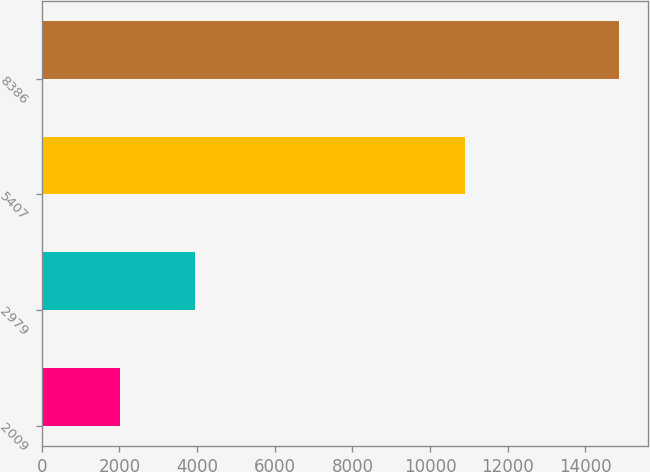<chart> <loc_0><loc_0><loc_500><loc_500><bar_chart><fcel>2009<fcel>2979<fcel>5407<fcel>8386<nl><fcel>2008<fcel>3955<fcel>10909<fcel>14864<nl></chart> 